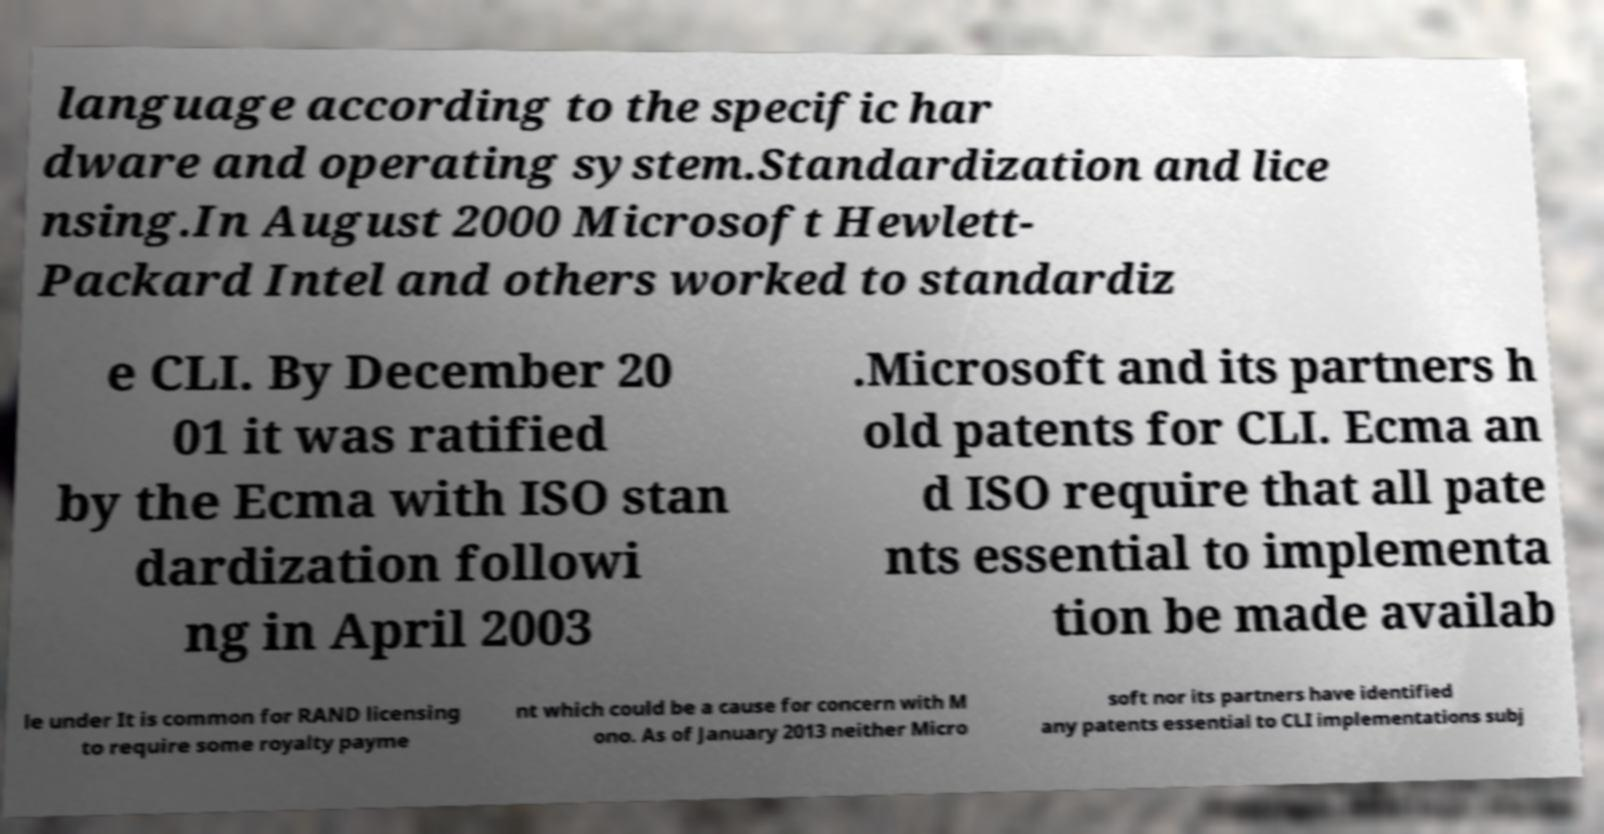What messages or text are displayed in this image? I need them in a readable, typed format. language according to the specific har dware and operating system.Standardization and lice nsing.In August 2000 Microsoft Hewlett- Packard Intel and others worked to standardiz e CLI. By December 20 01 it was ratified by the Ecma with ISO stan dardization followi ng in April 2003 .Microsoft and its partners h old patents for CLI. Ecma an d ISO require that all pate nts essential to implementa tion be made availab le under It is common for RAND licensing to require some royalty payme nt which could be a cause for concern with M ono. As of January 2013 neither Micro soft nor its partners have identified any patents essential to CLI implementations subj 